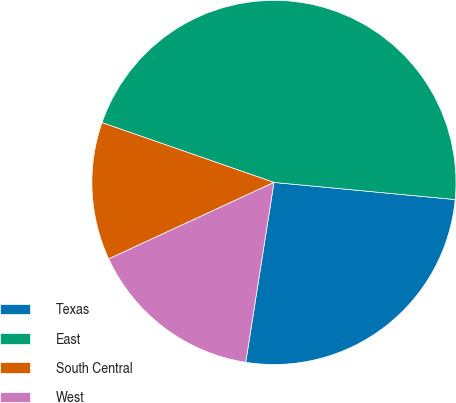<chart> <loc_0><loc_0><loc_500><loc_500><pie_chart><fcel>Texas<fcel>East<fcel>South Central<fcel>West<nl><fcel>25.98%<fcel>46.17%<fcel>12.23%<fcel>15.62%<nl></chart> 